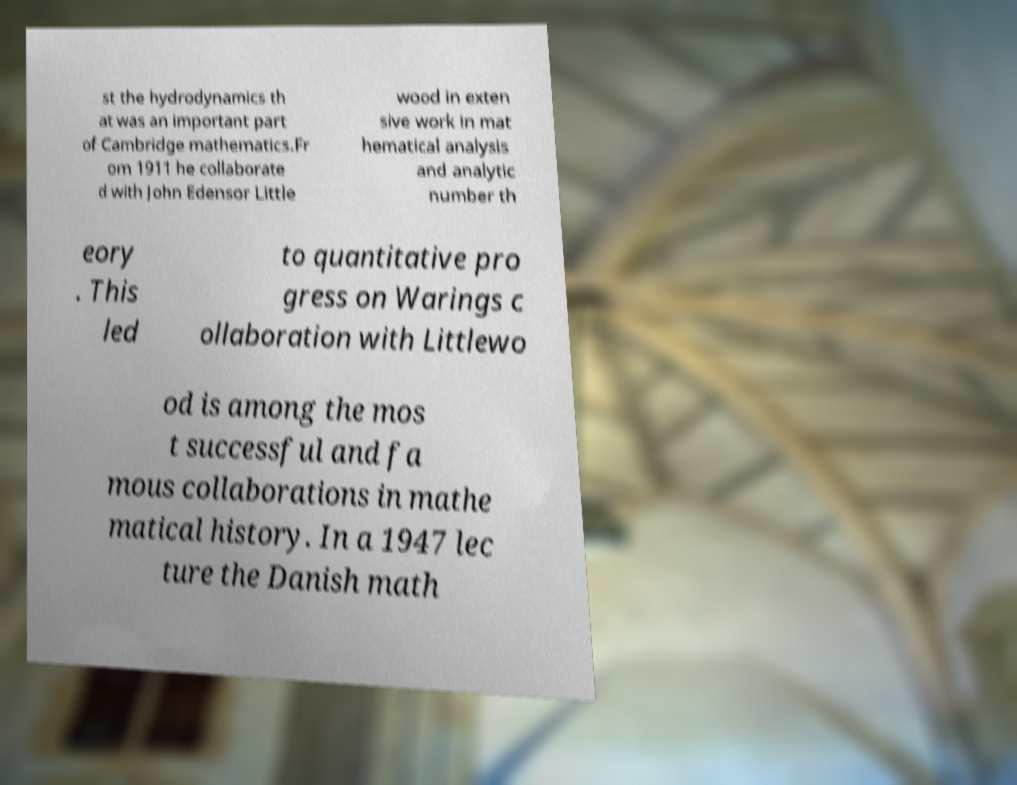What messages or text are displayed in this image? I need them in a readable, typed format. st the hydrodynamics th at was an important part of Cambridge mathematics.Fr om 1911 he collaborate d with John Edensor Little wood in exten sive work in mat hematical analysis and analytic number th eory . This led to quantitative pro gress on Warings c ollaboration with Littlewo od is among the mos t successful and fa mous collaborations in mathe matical history. In a 1947 lec ture the Danish math 